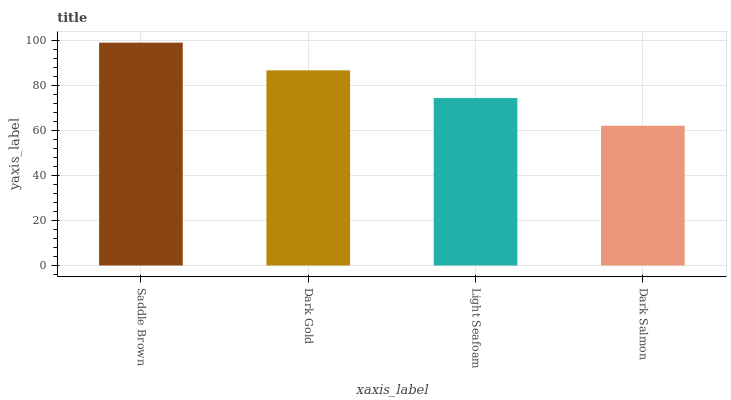Is Dark Salmon the minimum?
Answer yes or no. Yes. Is Saddle Brown the maximum?
Answer yes or no. Yes. Is Dark Gold the minimum?
Answer yes or no. No. Is Dark Gold the maximum?
Answer yes or no. No. Is Saddle Brown greater than Dark Gold?
Answer yes or no. Yes. Is Dark Gold less than Saddle Brown?
Answer yes or no. Yes. Is Dark Gold greater than Saddle Brown?
Answer yes or no. No. Is Saddle Brown less than Dark Gold?
Answer yes or no. No. Is Dark Gold the high median?
Answer yes or no. Yes. Is Light Seafoam the low median?
Answer yes or no. Yes. Is Dark Salmon the high median?
Answer yes or no. No. Is Saddle Brown the low median?
Answer yes or no. No. 